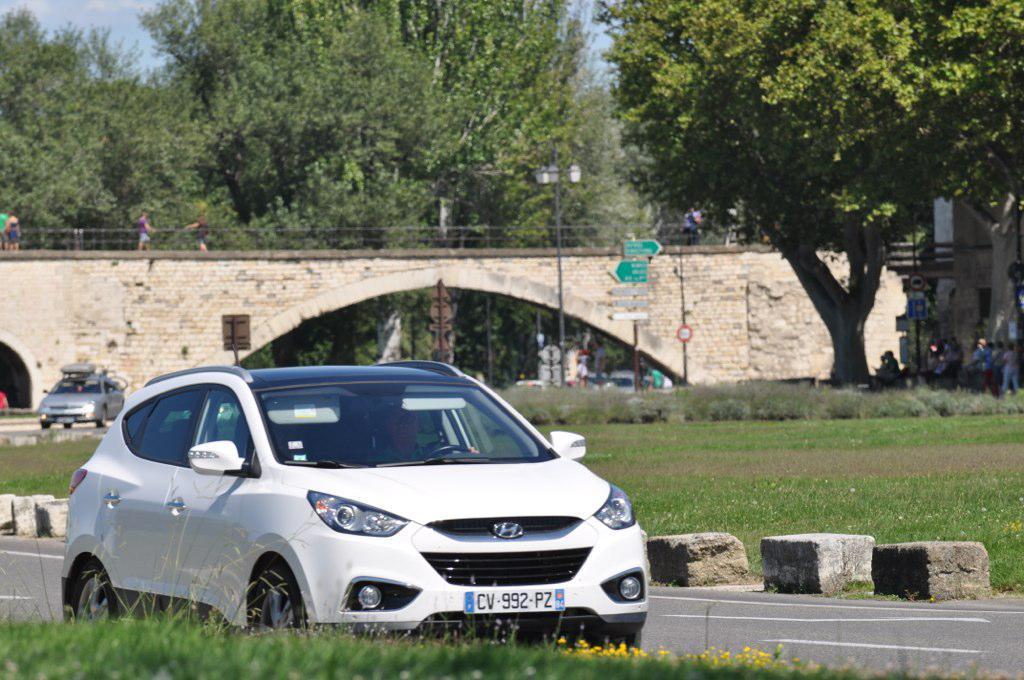Describe this image in one or two sentences. In this image we can see a few people, some of them are standing on the bridge, some people are sitting on the benches, there are two cars on the road, there are poles, signboards, light pole, there are trees, grass, also we can see the sky.  